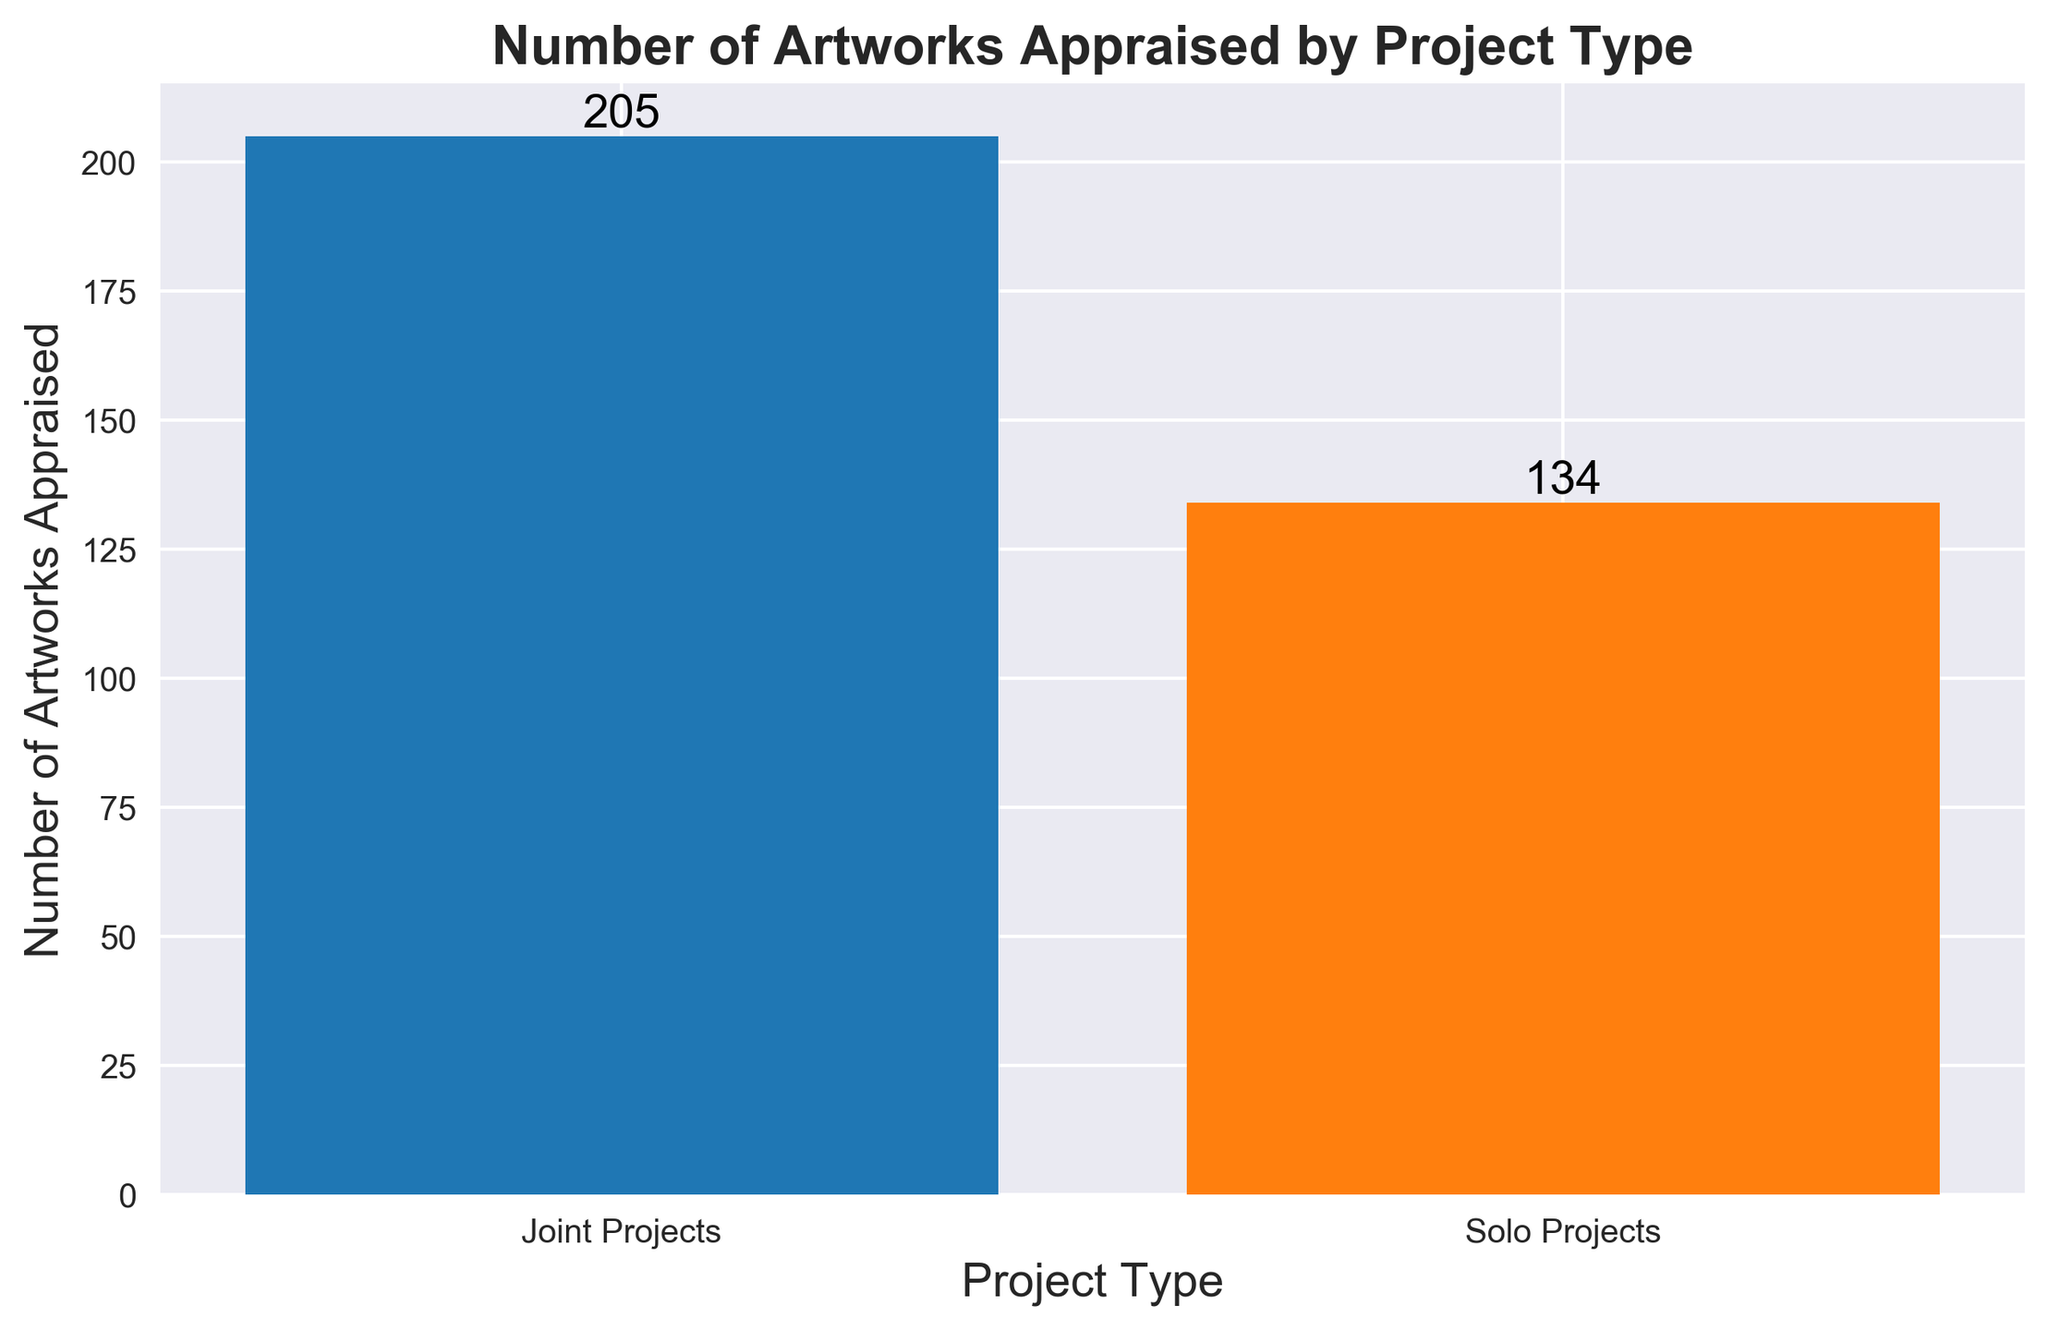What's the total number of artworks appraised in joint projects? To find the total number, sum the values associated with joint projects: 25 + 30 + 28 + 35 + 27 + 31 + 29 = 205
Answer: 205 How many more artworks were appraised in joint projects compared to solo projects? First, find the total number of artworks in joint projects (205) and solo projects (134), then subtract the total for solo projects from the total for joint projects: 205 - 134 = 71
Answer: 71 Which project type has a higher total number of artworks appraised? By comparing the totals for each project type, joint projects have 205 artworks, and solo projects have 134 artworks. Therefore, joint projects have a higher total number of artworks appraised.
Answer: Joint projects What is the average number of artworks appraised per joint project? Sum the counts for joint projects (205) and divide by the number of joint projects (7): 205 / 7 = 29.29
Answer: 29.29 What is the visual indication of the number of artworks appraised for each project type? The height of the bars represents the number of artworks appraised. The bar for joint projects is taller, indicating a higher number. The joint projects bar is also dark blue, and the solo projects bar is orange.
Answer: Height of the bars and colors How many solo projects were included in the data? Count the occurrences of solo projects: 15, 18, 22, 20, 19, 17, 23. The number of occurrences is 7.
Answer: 7 What's the average number of artworks appraised per solo project? Sum the counts for solo projects (134) and divide by the number of solo projects (7): 134 / 7 = 19.14
Answer: 19.14 How does the total for joint projects compare to the total for solo projects visually? The bar for joint projects is significantly taller than the bar for solo projects. This visual difference indicates a higher total count for joint projects.
Answer: Taller bar Which project type showed a wider range in the number of artworks appraised per project? Joint projects ranged from 25 to 35 artworks appraised, and solo projects ranged from 15 to 23. Joint projects have a range of 35 - 25 = 10, and solo projects have a range of 23 - 15 = 8. Thus, joint projects show a wider range.
Answer: Joint projects 